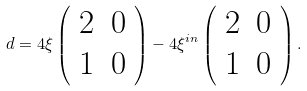Convert formula to latex. <formula><loc_0><loc_0><loc_500><loc_500>d = 4 \xi \left ( \begin{array} { c c } 2 & 0 \\ 1 & 0 \\ \end{array} \right ) - 4 \xi ^ { i n } \left ( \begin{array} { c c } 2 & 0 \\ 1 & 0 \\ \end{array} \right ) .</formula> 